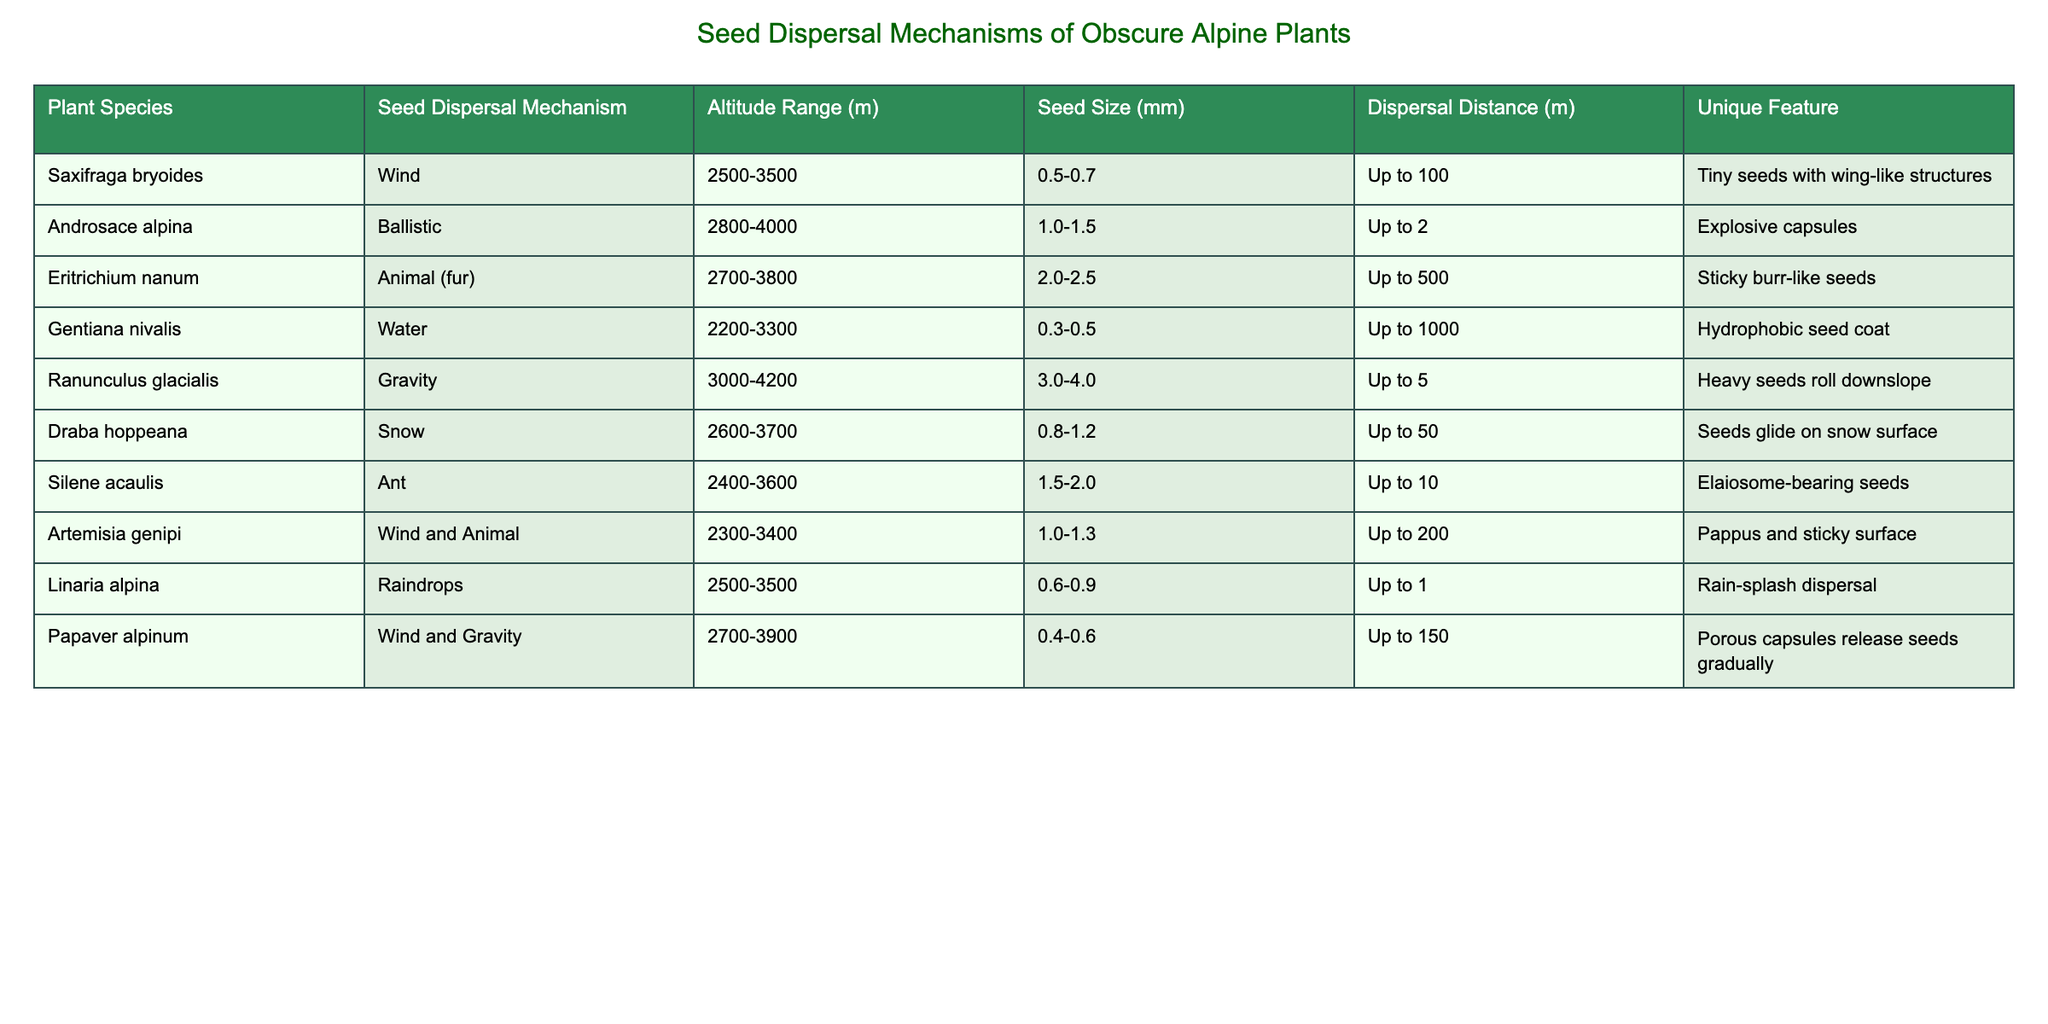What is the seed dispersal mechanism of Saxifraga bryoides? The table indicates that Saxifraga bryoides uses wind as its seed dispersal mechanism.
Answer: Wind Which alpine plant has the largest seed size? Looking through the seed size column, I see that Ranunculus glacialis has the largest seed size, measuring between 3.0 to 4.0 mm.
Answer: 3.0-4.0 mm Are there any plants that use more than one seed dispersal mechanism? From the table, both Artemisia genipi and Papaver alpinum are listed with multiple seed dispersal mechanisms: Artemisia genipi uses wind and animal, while Papaver alpinum uses wind and gravity. Thus, the answer is yes.
Answer: Yes What is the maximum dispersal distance for seeds of Eritrichium nanum? The table shows that Eritrichium nanum can disperse its seeds up to 500 meters, which indicates its comparative advantage in seed dispersal distance.
Answer: Up to 500 What is the unique feature of seeds dispersed by Draba hoppeana? The unique feature listed for Draba hoppeana is that its seeds glide on the snow surface, which aids in their dispersal in alpine conditions.
Answer: Seeds glide on snow surface Which plant has the shortest maximum dispersal distance, and what is that distance? By examining the dispersal distance column, I find that Silene acaulis has the shortest maximum distance at up to 10 meters. This distinguishes it from others.
Answer: Silene acaulis, Up to 10 m What is the average altitude range of the plants listed in the table? The altitude ranges of the plants are: (2500-3500), (2800-4000), (2700-3800), (2200-3300), (3000-4200), (2600-3700), (2400-3600), (2300-3400), (2500-3500), (2700-3900). Calculating the average requires taking the midpoints of the ranges: 3000, 3400, 3200, 2750, 3600, 3150, 3000, 2850, 3000, and 3300. The average of these midpoints is approximately 3085 meters.
Answer: 3085 m Which seed dispersal mechanism is most commonly used among the plants listed? I count the occurrences of each seed dispersal mechanism in the table: wind appears 4 times, animal 3 times, gravity 2 times, ballistic 1 time, water 1 time, raindrops 1 time, snow 1 time. Wind is the most common mechanism, appearing four times.
Answer: Wind Is the seed size of Papaver alpinum larger than that of Saxifraga bryoides? By comparing seed sizes from the table, Papaver alpinum has a size of 0.4-0.6 mm while Saxifraga bryoides has 0.5-0.7 mm. Since both ranges overlap and are relatively close, Papaver alpinum's maximum is smaller than Saxifraga's minimum. Thus, the answer is no.
Answer: No 